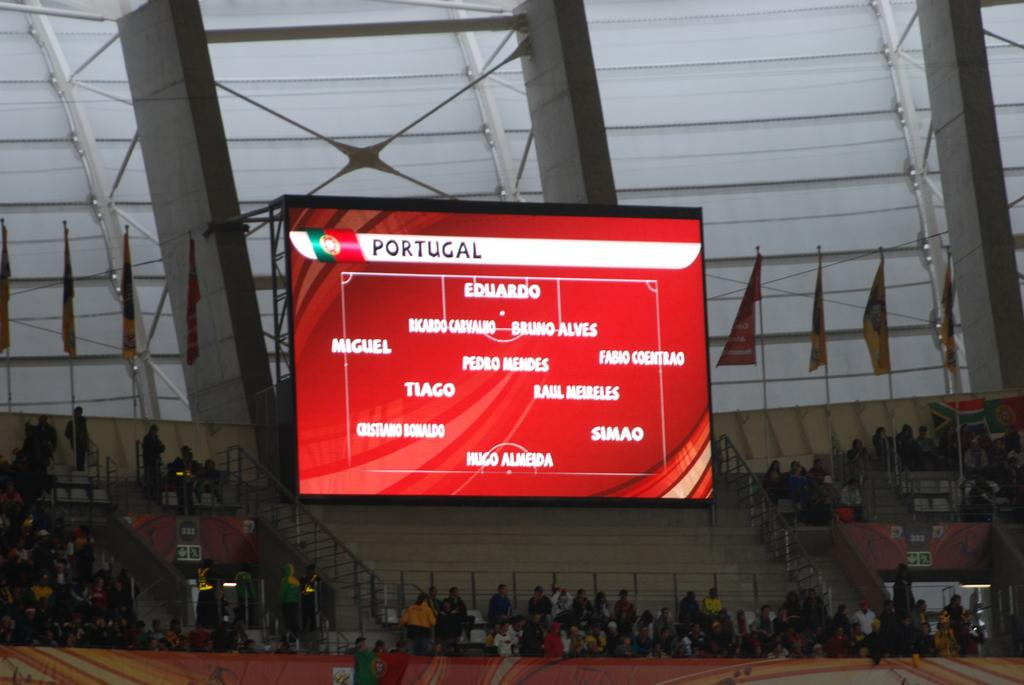<image>
Present a compact description of the photo's key features. the name Portugal is on the red screen 